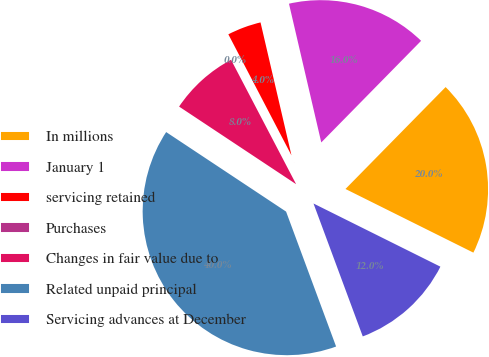Convert chart. <chart><loc_0><loc_0><loc_500><loc_500><pie_chart><fcel>In millions<fcel>January 1<fcel>servicing retained<fcel>Purchases<fcel>Changes in fair value due to<fcel>Related unpaid principal<fcel>Servicing advances at December<nl><fcel>19.99%<fcel>16.0%<fcel>4.01%<fcel>0.02%<fcel>8.01%<fcel>39.97%<fcel>12.0%<nl></chart> 